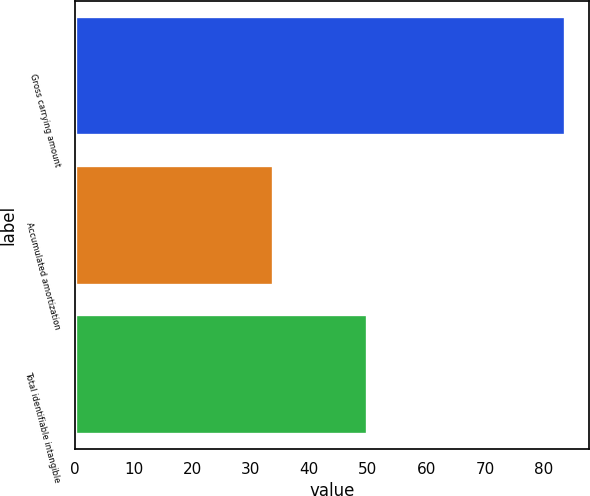Convert chart to OTSL. <chart><loc_0><loc_0><loc_500><loc_500><bar_chart><fcel>Gross carrying amount<fcel>Accumulated amortization<fcel>Total identifiable intangible<nl><fcel>83.6<fcel>33.8<fcel>49.8<nl></chart> 